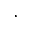Convert formula to latex. <formula><loc_0><loc_0><loc_500><loc_500>,</formula> 